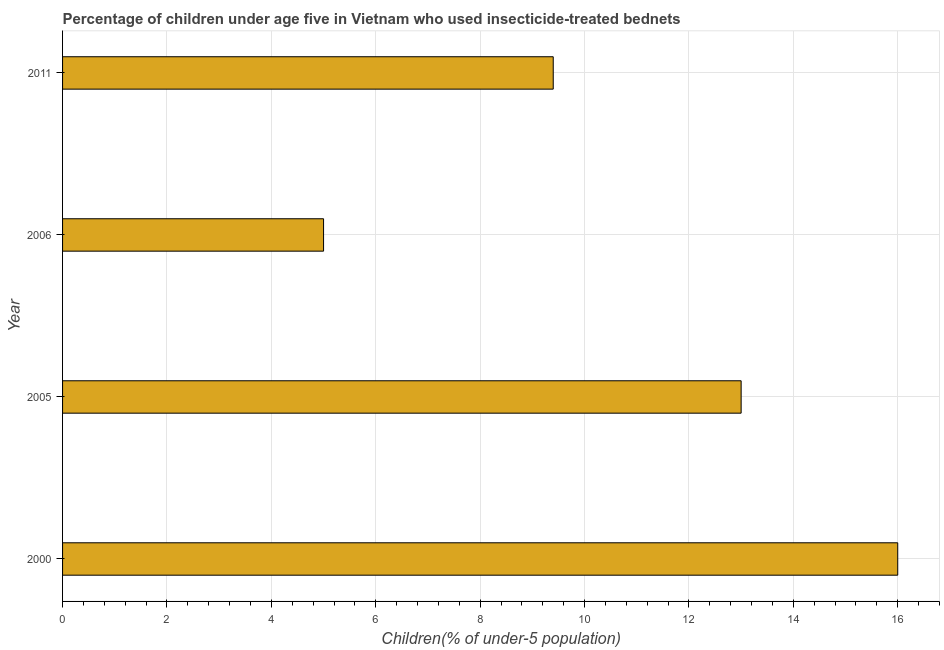Does the graph contain any zero values?
Your answer should be very brief. No. Does the graph contain grids?
Your answer should be compact. Yes. What is the title of the graph?
Your answer should be very brief. Percentage of children under age five in Vietnam who used insecticide-treated bednets. What is the label or title of the X-axis?
Give a very brief answer. Children(% of under-5 population). What is the percentage of children who use of insecticide-treated bed nets in 2005?
Provide a short and direct response. 13. Across all years, what is the maximum percentage of children who use of insecticide-treated bed nets?
Give a very brief answer. 16. Across all years, what is the minimum percentage of children who use of insecticide-treated bed nets?
Make the answer very short. 5. What is the sum of the percentage of children who use of insecticide-treated bed nets?
Offer a terse response. 43.4. What is the difference between the percentage of children who use of insecticide-treated bed nets in 2005 and 2006?
Offer a very short reply. 8. What is the average percentage of children who use of insecticide-treated bed nets per year?
Your answer should be very brief. 10.85. What is the median percentage of children who use of insecticide-treated bed nets?
Make the answer very short. 11.2. In how many years, is the percentage of children who use of insecticide-treated bed nets greater than 14 %?
Provide a succinct answer. 1. What is the ratio of the percentage of children who use of insecticide-treated bed nets in 2006 to that in 2011?
Make the answer very short. 0.53. Is the percentage of children who use of insecticide-treated bed nets in 2000 less than that in 2005?
Provide a succinct answer. No. What is the difference between the highest and the second highest percentage of children who use of insecticide-treated bed nets?
Give a very brief answer. 3. What is the difference between the highest and the lowest percentage of children who use of insecticide-treated bed nets?
Provide a succinct answer. 11. How many bars are there?
Provide a short and direct response. 4. What is the difference between two consecutive major ticks on the X-axis?
Provide a short and direct response. 2. What is the Children(% of under-5 population) in 2000?
Keep it short and to the point. 16. What is the difference between the Children(% of under-5 population) in 2000 and 2005?
Provide a short and direct response. 3. What is the difference between the Children(% of under-5 population) in 2000 and 2006?
Offer a terse response. 11. What is the difference between the Children(% of under-5 population) in 2000 and 2011?
Make the answer very short. 6.6. What is the difference between the Children(% of under-5 population) in 2005 and 2006?
Provide a succinct answer. 8. What is the ratio of the Children(% of under-5 population) in 2000 to that in 2005?
Offer a terse response. 1.23. What is the ratio of the Children(% of under-5 population) in 2000 to that in 2006?
Make the answer very short. 3.2. What is the ratio of the Children(% of under-5 population) in 2000 to that in 2011?
Provide a short and direct response. 1.7. What is the ratio of the Children(% of under-5 population) in 2005 to that in 2006?
Ensure brevity in your answer.  2.6. What is the ratio of the Children(% of under-5 population) in 2005 to that in 2011?
Provide a short and direct response. 1.38. What is the ratio of the Children(% of under-5 population) in 2006 to that in 2011?
Your response must be concise. 0.53. 